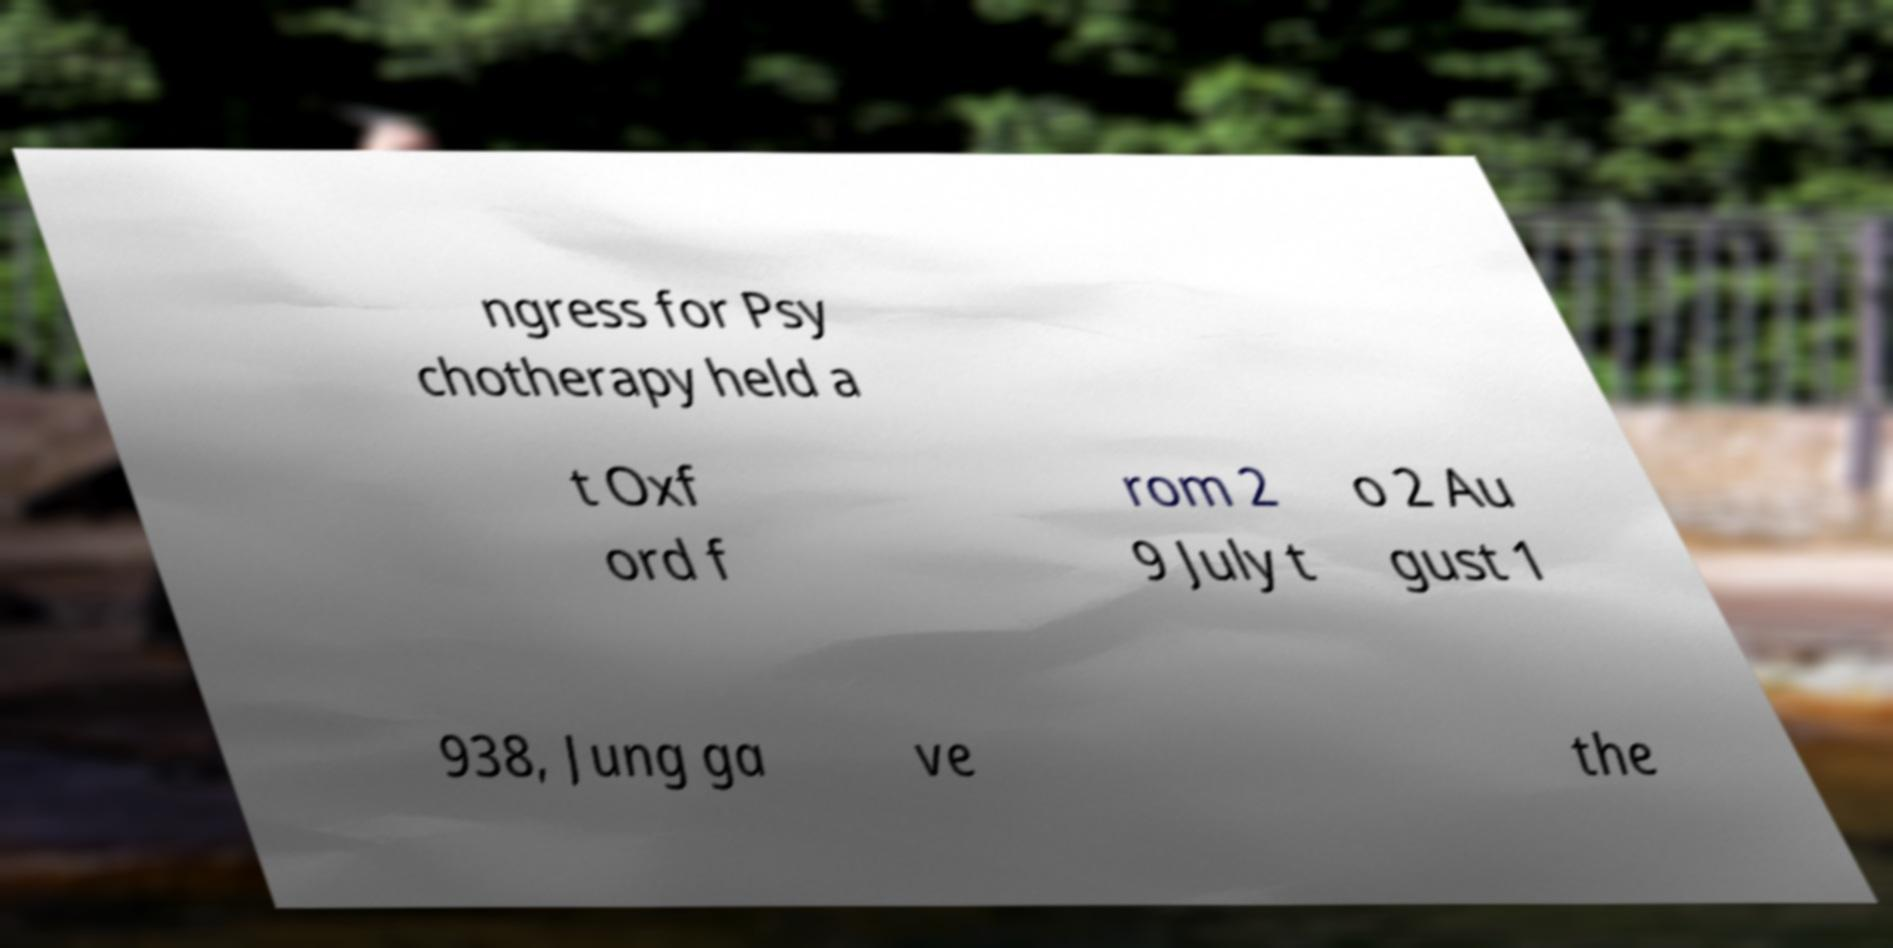Can you read and provide the text displayed in the image?This photo seems to have some interesting text. Can you extract and type it out for me? ngress for Psy chotherapy held a t Oxf ord f rom 2 9 July t o 2 Au gust 1 938, Jung ga ve the 